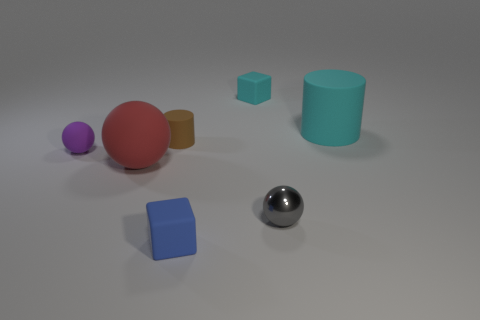Subtract all matte balls. How many balls are left? 1 Add 2 green shiny spheres. How many objects exist? 9 Subtract all cubes. How many objects are left? 5 Add 3 tiny spheres. How many tiny spheres exist? 5 Subtract 0 blue cylinders. How many objects are left? 7 Subtract all cyan rubber blocks. Subtract all cyan rubber cubes. How many objects are left? 5 Add 3 blue rubber objects. How many blue rubber objects are left? 4 